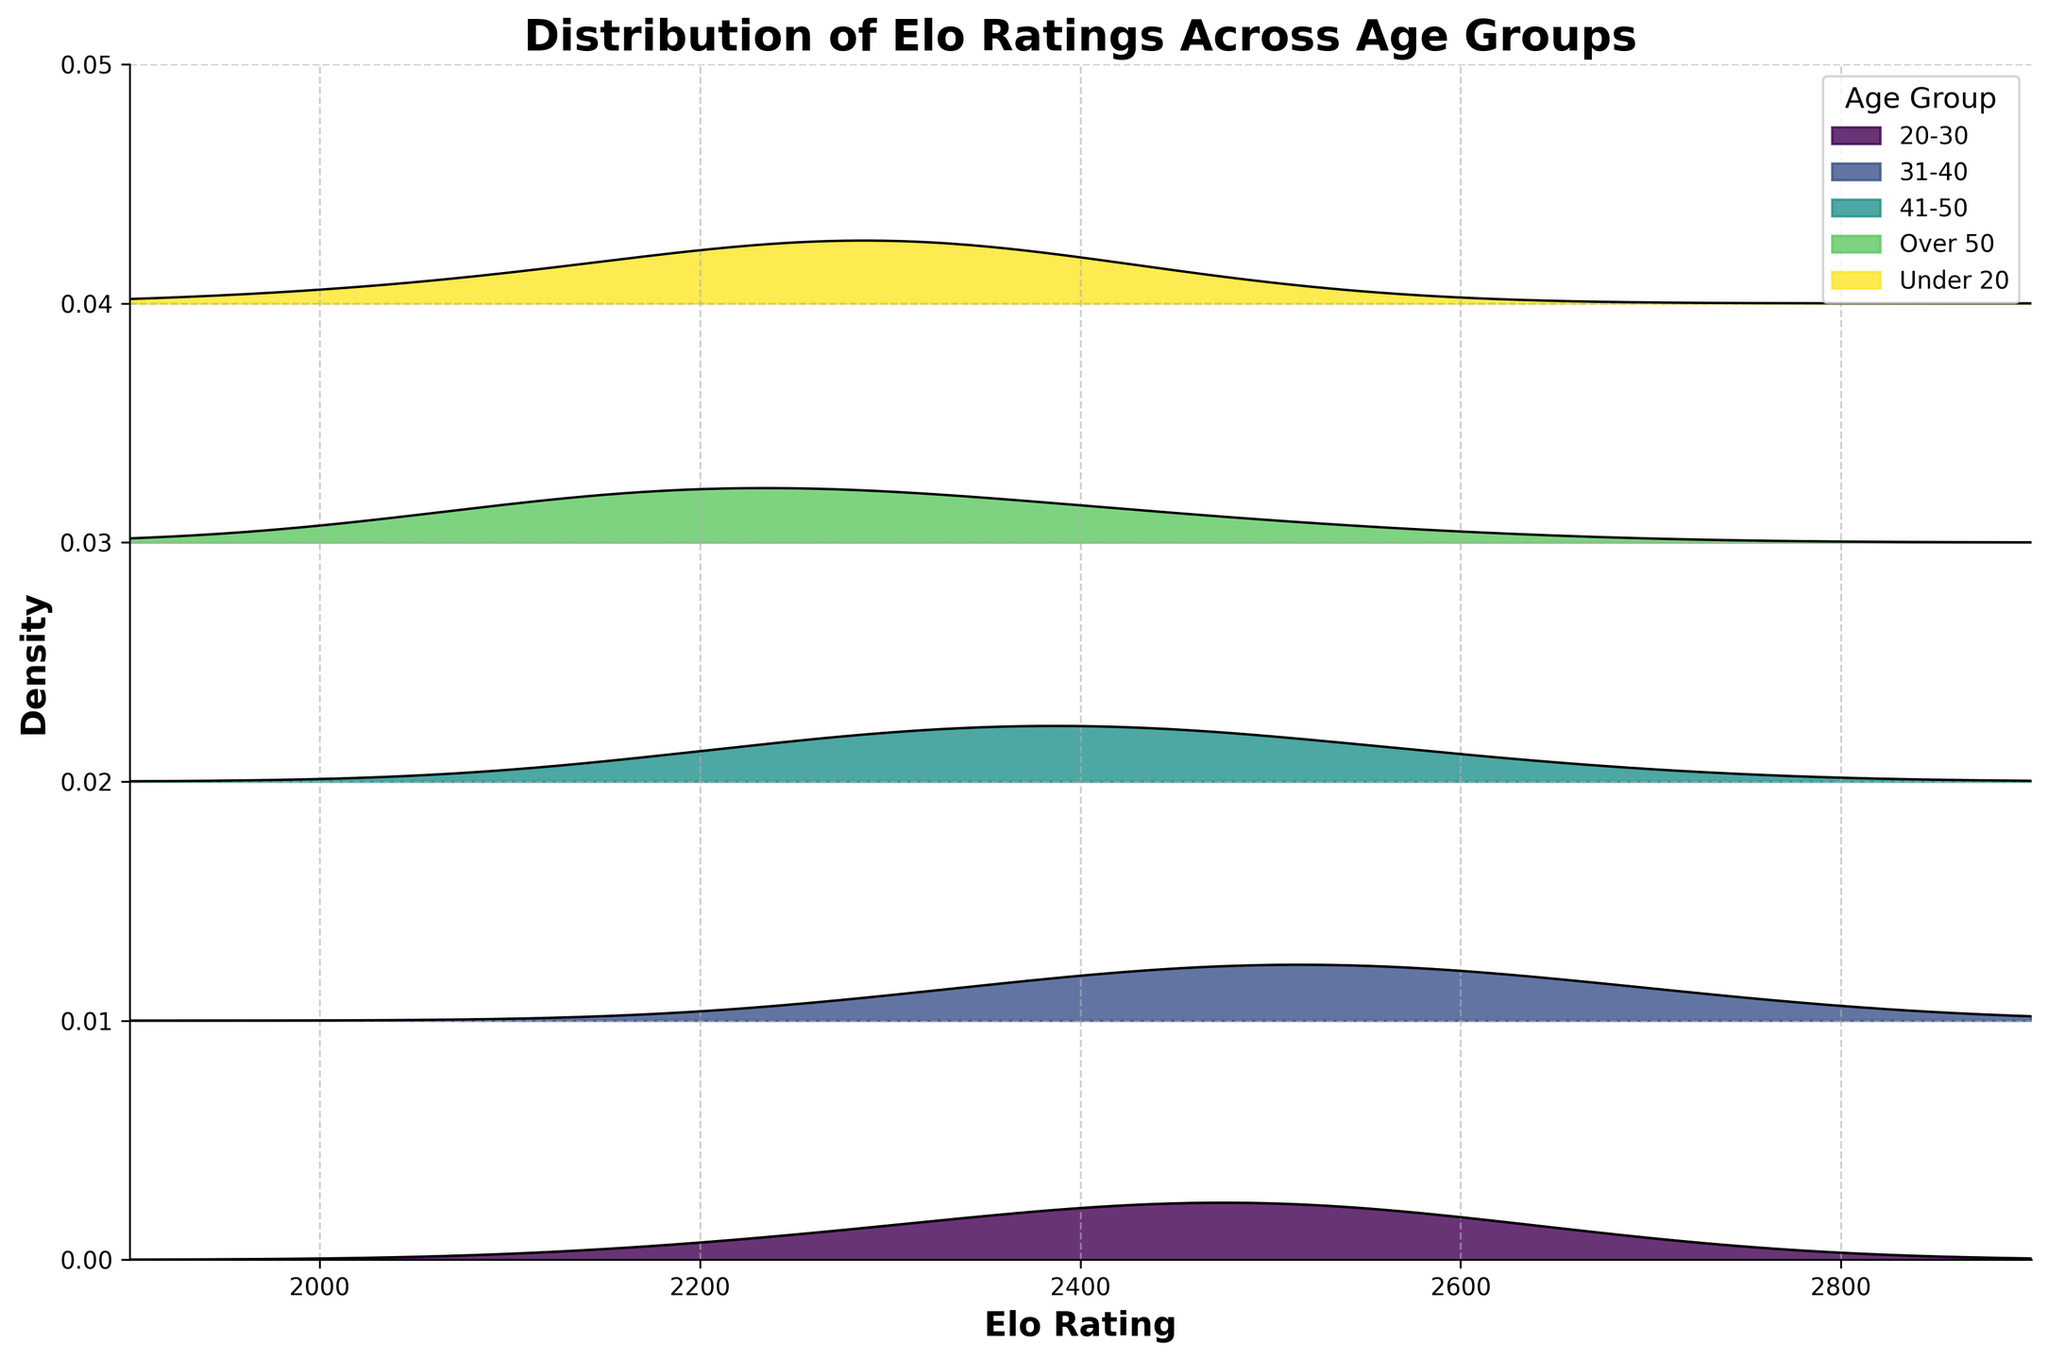What is the title of the plot? The title of the plot is typically displayed at the top and is designed to summarize the main focus of the visualized data. The title reads "Distribution of Elo Ratings Across Age Groups".
Answer: Distribution of Elo Ratings Across Age Groups Which age group has the highest peak in Elo rating density? To determine the highest peak, look for the age group with the tallest density curve. The 20-30 age group has the highest peak around the Elo rating of 2500.
Answer: 20-30 What is the range of Elo ratings displayed on the x-axis? The range of the x-axis is the interval between the minimum and maximum values shown. The Elo ratings range from 1900 to 2900.
Answer: 1900 to 2900 Which two age groups appear to have the most overlap in their Elo rating distributions? To determine overlap, observe where the density curves from different age groups intersect or lie close together. The 20-30 and 31-40 age groups show significant overlap in their distributions around the 2200-2800 Elo rating areas.
Answer: 20-30 and 31-40 What is the Elo rating where the density for the Under 20 age group starts to drop significantly? Identify the point on the x-axis where the density curve for the Under 20 age group begins to decline sharply. The significant drop starts around the 2300 Elo rating.
Answer: 2300 How do the distributions of Elo ratings compare between the 31-40 and 41-50 age groups? Compare the density curves of the two age groups, looking at their spread and peaks. The 31-40 age group has a wider spread and peaks around 2500, whereas the 41-50 group peaks lower around 2300-2400 and has a more concentrated distribution.
Answer: The 31-40 age group has a wider spread with a peak around 2500, while the 41-50 group peaks around 2300-2400 and is more concentrated Which age group has the lowest density at an Elo rating of 2500? Observe the y-axis value (density) for each age group's curve at the Elo rating of 2500. The Over 50 age group has the lowest density at this Elo rating.
Answer: Over 50 At what Elo rating does the 41-50 age group’s density peak? Locate the highest point on the density curve for the 41-50 age group. The peak density occurs at an Elo rating of 2400.
Answer: 2400 Which age group has the most skewed distribution towards higher Elo ratings? Look for the age group where the density curve is more concentrated on the higher end of the x-axis (Elo ratings). The 20-30 and 31-40 age groups show distributions skewed towards higher Elo ratings, with 31-40 slightly more skewed.
Answer: 31-40 What is the total number of age groups shown in the plot? Count the distinct color-filled areas representing the density curves for different age groups. There are five age groups displayed.
Answer: Five 